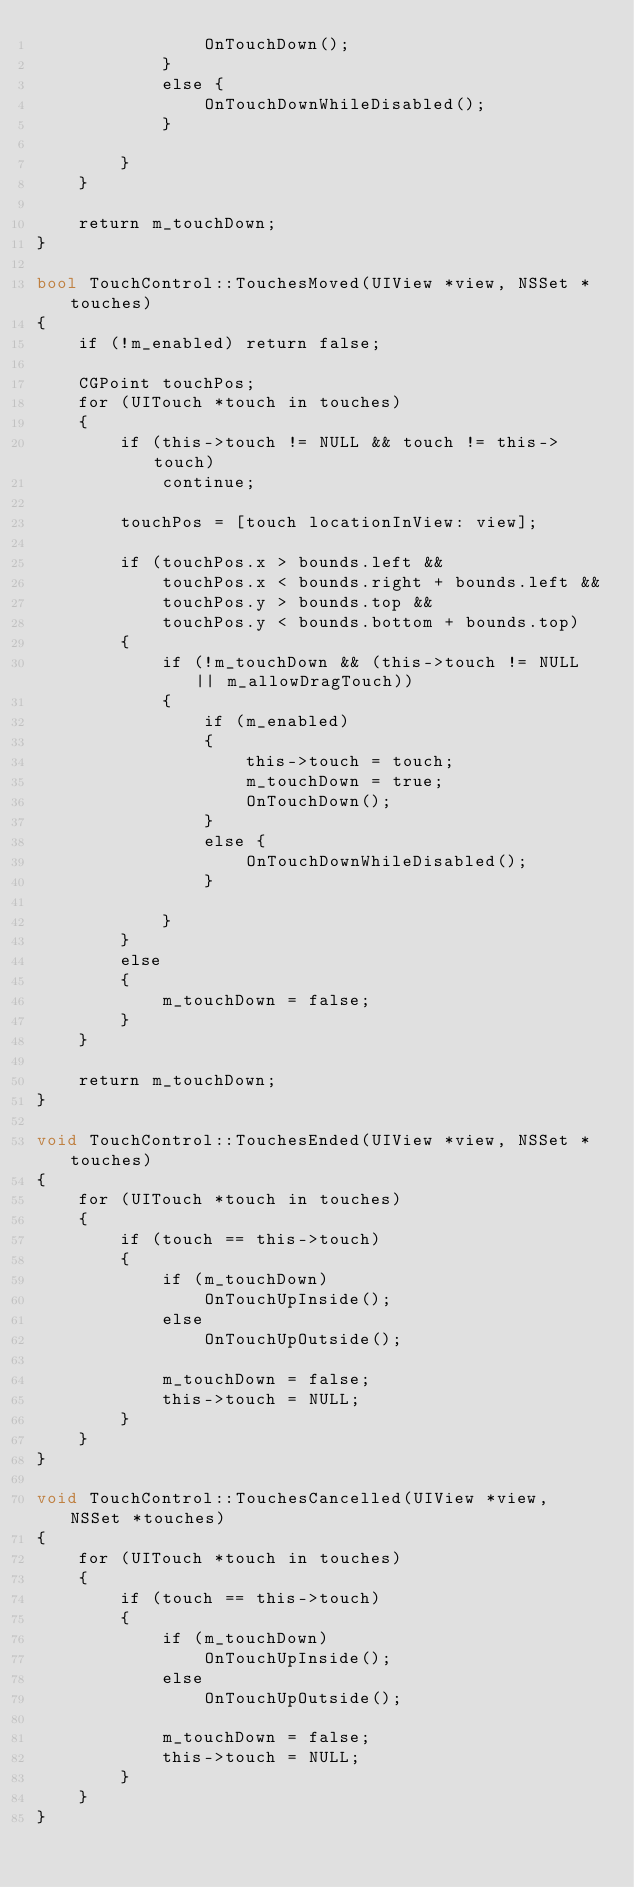Convert code to text. <code><loc_0><loc_0><loc_500><loc_500><_ObjectiveC_>				OnTouchDown();
			}
			else {
				OnTouchDownWhileDisabled();
			}

		}
	}
	
	return m_touchDown;
}

bool TouchControl::TouchesMoved(UIView *view, NSSet *touches)
{
	if (!m_enabled) return false;
	
	CGPoint touchPos;
	for (UITouch *touch in touches)
	{
		if (this->touch != NULL && touch != this->touch)
			continue;
		
		touchPos = [touch locationInView: view];
		
		if (touchPos.x > bounds.left && 
			touchPos.x < bounds.right + bounds.left &&
			touchPos.y > bounds.top &&
			touchPos.y < bounds.bottom + bounds.top)
		{						
			if (!m_touchDown && (this->touch != NULL || m_allowDragTouch))
			{
				if (m_enabled)
				{
					this->touch = touch;
					m_touchDown = true;
					OnTouchDown();
				}
				else {
					OnTouchDownWhileDisabled();
				}

			}
		}
		else
		{
			m_touchDown = false;
		}
	}
	
	return m_touchDown;
}

void TouchControl::TouchesEnded(UIView *view, NSSet *touches)
{
	for (UITouch *touch in touches)
	{
		if (touch == this->touch)
		{
			if (m_touchDown)
				OnTouchUpInside();
			else
				OnTouchUpOutside();
			
			m_touchDown = false;
			this->touch = NULL;
		}
	}
}

void TouchControl::TouchesCancelled(UIView *view, NSSet *touches)
{
	for (UITouch *touch in touches)
	{
		if (touch == this->touch)
		{
			if (m_touchDown)
				OnTouchUpInside();
			else
				OnTouchUpOutside();
			
			m_touchDown = false;
			this->touch = NULL;
		}
	}
}

</code> 